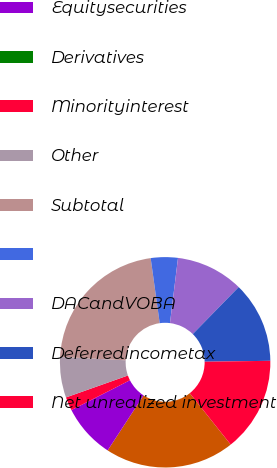<chart> <loc_0><loc_0><loc_500><loc_500><pie_chart><fcel>Fixed maturity securities<fcel>Equitysecurities<fcel>Derivatives<fcel>Minorityinterest<fcel>Other<fcel>Subtotal<fcel>Unnamed: 6<fcel>DACandVOBA<fcel>Deferredincometax<fcel>Net unrealized investment<nl><fcel>19.91%<fcel>8.3%<fcel>0.0%<fcel>2.08%<fcel>6.23%<fcel>21.99%<fcel>4.15%<fcel>10.37%<fcel>12.45%<fcel>14.52%<nl></chart> 